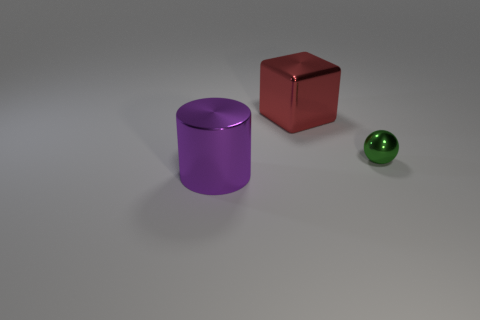How would you describe the texture of the objects? The objects appear to have smooth surfaces with the shiny sphere reflecting light, indicating a glossy texture, while the red cube and the purple cylinder have more of a matte finish. 